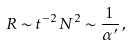Convert formula to latex. <formula><loc_0><loc_0><loc_500><loc_500>R \sim t ^ { - 2 } \, N ^ { 2 } \sim \frac { 1 } { \alpha ^ { \prime } } \, ,</formula> 